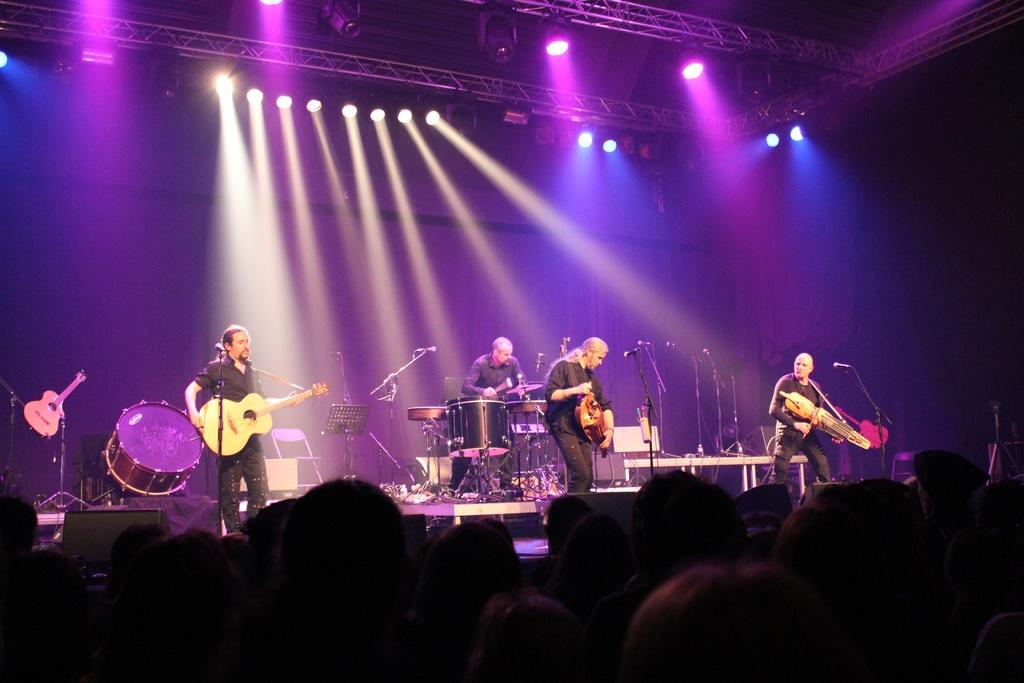What is happening in the image? There are people in the image, and they are playing musical instruments. Where are the people located in the image? The people are standing on a stage. What type of honey is being collected from the branch in the image? There is no honey or branch present in the image; it features people playing musical instruments on a stage. Can you tell me how many grandmothers are visible in the image? There is no grandmother present in the image. 